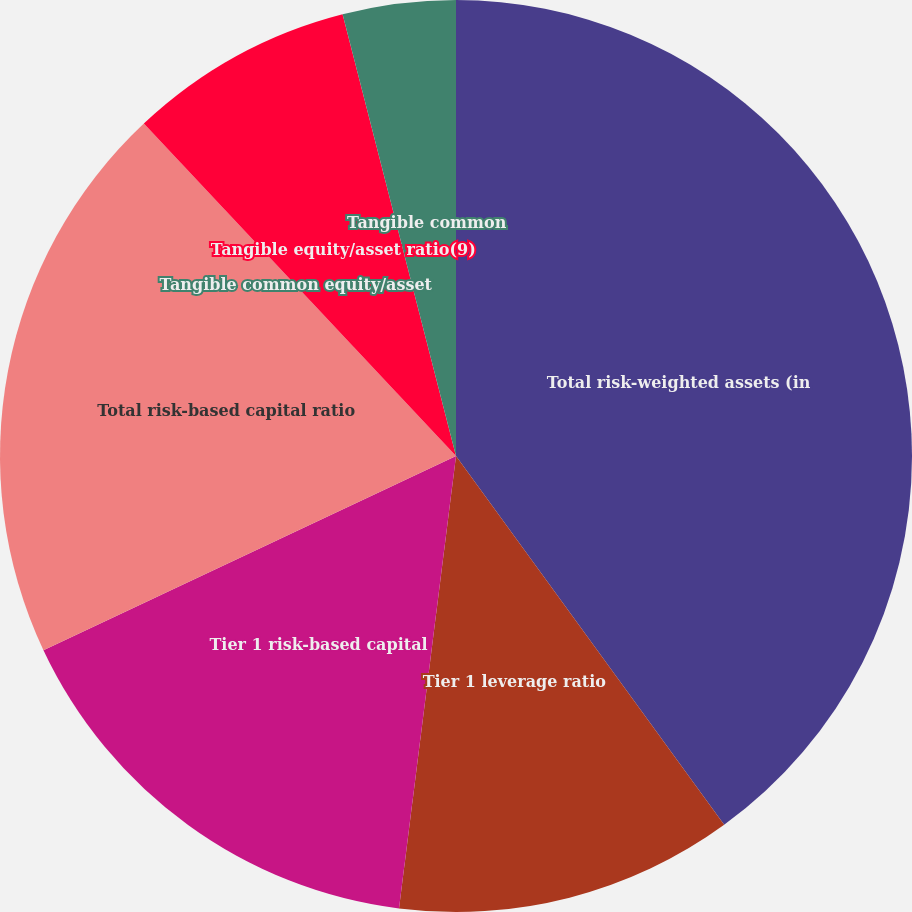<chart> <loc_0><loc_0><loc_500><loc_500><pie_chart><fcel>Total risk-weighted assets (in<fcel>Tier 1 leverage ratio<fcel>Tier 1 risk-based capital<fcel>Total risk-based capital ratio<fcel>Tangible common equity/asset<fcel>Tangible equity/asset ratio(9)<fcel>Tangible common<nl><fcel>39.99%<fcel>12.0%<fcel>16.0%<fcel>20.0%<fcel>0.0%<fcel>8.0%<fcel>4.0%<nl></chart> 